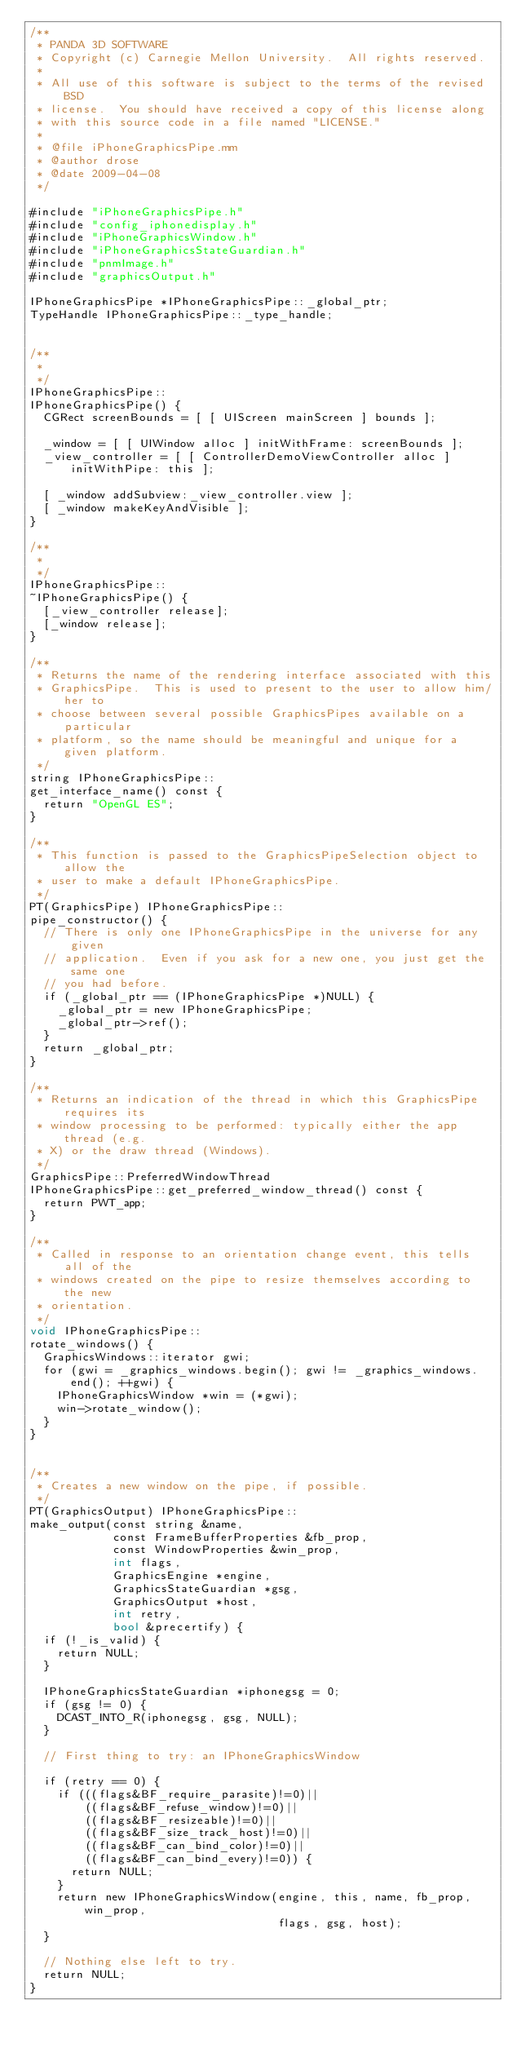Convert code to text. <code><loc_0><loc_0><loc_500><loc_500><_ObjectiveC_>/**
 * PANDA 3D SOFTWARE
 * Copyright (c) Carnegie Mellon University.  All rights reserved.
 *
 * All use of this software is subject to the terms of the revised BSD
 * license.  You should have received a copy of this license along
 * with this source code in a file named "LICENSE."
 *
 * @file iPhoneGraphicsPipe.mm
 * @author drose
 * @date 2009-04-08
 */

#include "iPhoneGraphicsPipe.h"
#include "config_iphonedisplay.h"
#include "iPhoneGraphicsWindow.h"
#include "iPhoneGraphicsStateGuardian.h"
#include "pnmImage.h"
#include "graphicsOutput.h"

IPhoneGraphicsPipe *IPhoneGraphicsPipe::_global_ptr;
TypeHandle IPhoneGraphicsPipe::_type_handle;


/**
 *
 */
IPhoneGraphicsPipe::
IPhoneGraphicsPipe() {
  CGRect screenBounds = [ [ UIScreen mainScreen ] bounds ];

  _window = [ [ UIWindow alloc ] initWithFrame: screenBounds ];
  _view_controller = [ [ ControllerDemoViewController alloc ] initWithPipe: this ];

  [ _window addSubview:_view_controller.view ];
  [ _window makeKeyAndVisible ];
}

/**
 *
 */
IPhoneGraphicsPipe::
~IPhoneGraphicsPipe() {
  [_view_controller release];
  [_window release];
}

/**
 * Returns the name of the rendering interface associated with this
 * GraphicsPipe.  This is used to present to the user to allow him/her to
 * choose between several possible GraphicsPipes available on a particular
 * platform, so the name should be meaningful and unique for a given platform.
 */
string IPhoneGraphicsPipe::
get_interface_name() const {
  return "OpenGL ES";
}

/**
 * This function is passed to the GraphicsPipeSelection object to allow the
 * user to make a default IPhoneGraphicsPipe.
 */
PT(GraphicsPipe) IPhoneGraphicsPipe::
pipe_constructor() {
  // There is only one IPhoneGraphicsPipe in the universe for any given
  // application.  Even if you ask for a new one, you just get the same one
  // you had before.
  if (_global_ptr == (IPhoneGraphicsPipe *)NULL) {
    _global_ptr = new IPhoneGraphicsPipe;
    _global_ptr->ref();
  }
  return _global_ptr;
}

/**
 * Returns an indication of the thread in which this GraphicsPipe requires its
 * window processing to be performed: typically either the app thread (e.g.
 * X) or the draw thread (Windows).
 */
GraphicsPipe::PreferredWindowThread
IPhoneGraphicsPipe::get_preferred_window_thread() const {
  return PWT_app;
}

/**
 * Called in response to an orientation change event, this tells all of the
 * windows created on the pipe to resize themselves according to the new
 * orientation.
 */
void IPhoneGraphicsPipe::
rotate_windows() {
  GraphicsWindows::iterator gwi;
  for (gwi = _graphics_windows.begin(); gwi != _graphics_windows.end(); ++gwi) {
    IPhoneGraphicsWindow *win = (*gwi);
    win->rotate_window();
  }
}


/**
 * Creates a new window on the pipe, if possible.
 */
PT(GraphicsOutput) IPhoneGraphicsPipe::
make_output(const string &name,
            const FrameBufferProperties &fb_prop,
            const WindowProperties &win_prop,
            int flags,
            GraphicsEngine *engine,
            GraphicsStateGuardian *gsg,
            GraphicsOutput *host,
            int retry,
            bool &precertify) {
  if (!_is_valid) {
    return NULL;
  }

  IPhoneGraphicsStateGuardian *iphonegsg = 0;
  if (gsg != 0) {
    DCAST_INTO_R(iphonegsg, gsg, NULL);
  }

  // First thing to try: an IPhoneGraphicsWindow

  if (retry == 0) {
    if (((flags&BF_require_parasite)!=0)||
        ((flags&BF_refuse_window)!=0)||
        ((flags&BF_resizeable)!=0)||
        ((flags&BF_size_track_host)!=0)||
        ((flags&BF_can_bind_color)!=0)||
        ((flags&BF_can_bind_every)!=0)) {
      return NULL;
    }
    return new IPhoneGraphicsWindow(engine, this, name, fb_prop, win_prop,
                                    flags, gsg, host);
  }

  // Nothing else left to try.
  return NULL;
}
</code> 